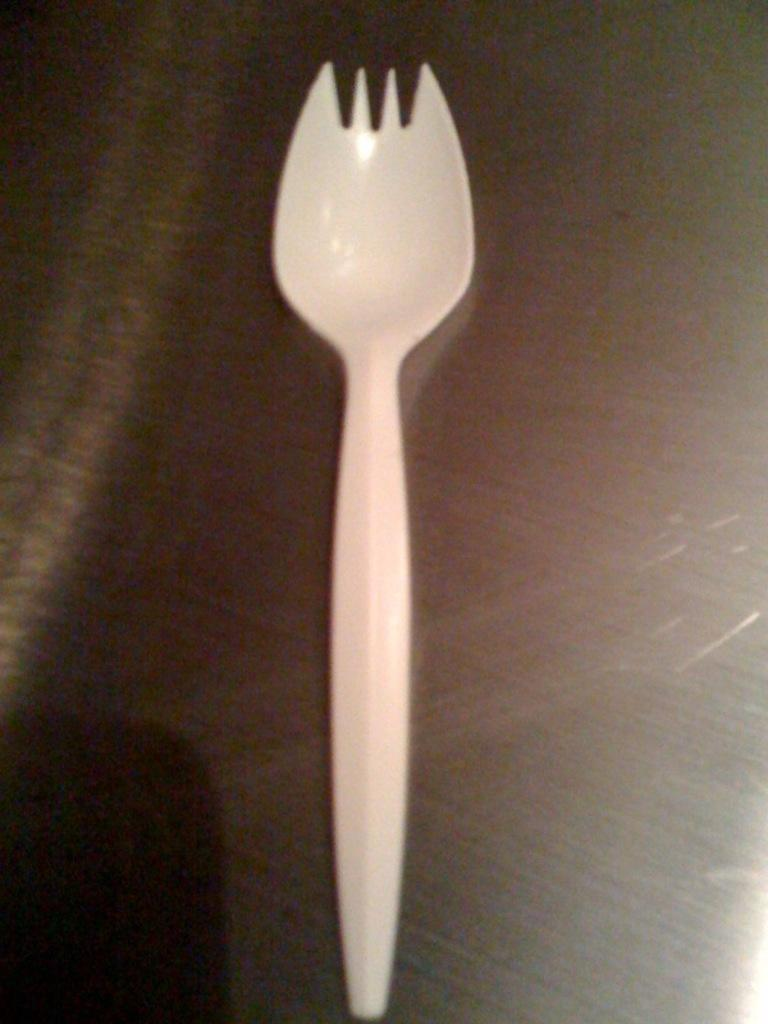What color is the fork that is visible in the image? The fork in the image is white. What type of fiction is the fork a part of in the image? The fork is not a part of any fiction in the image; it is a real object. What class of utensils does the fork belong to in the image? The fork is a part of the cutlery class of utensils in the image. 